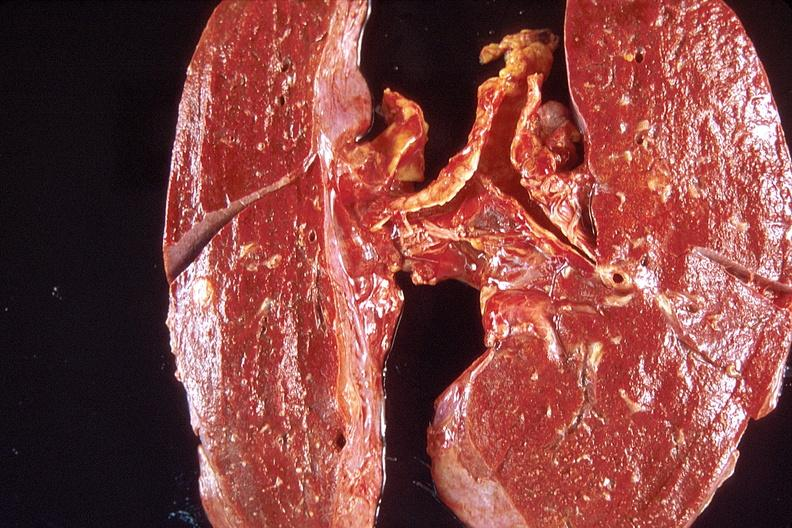what does this image show?
Answer the question using a single word or phrase. Lung 